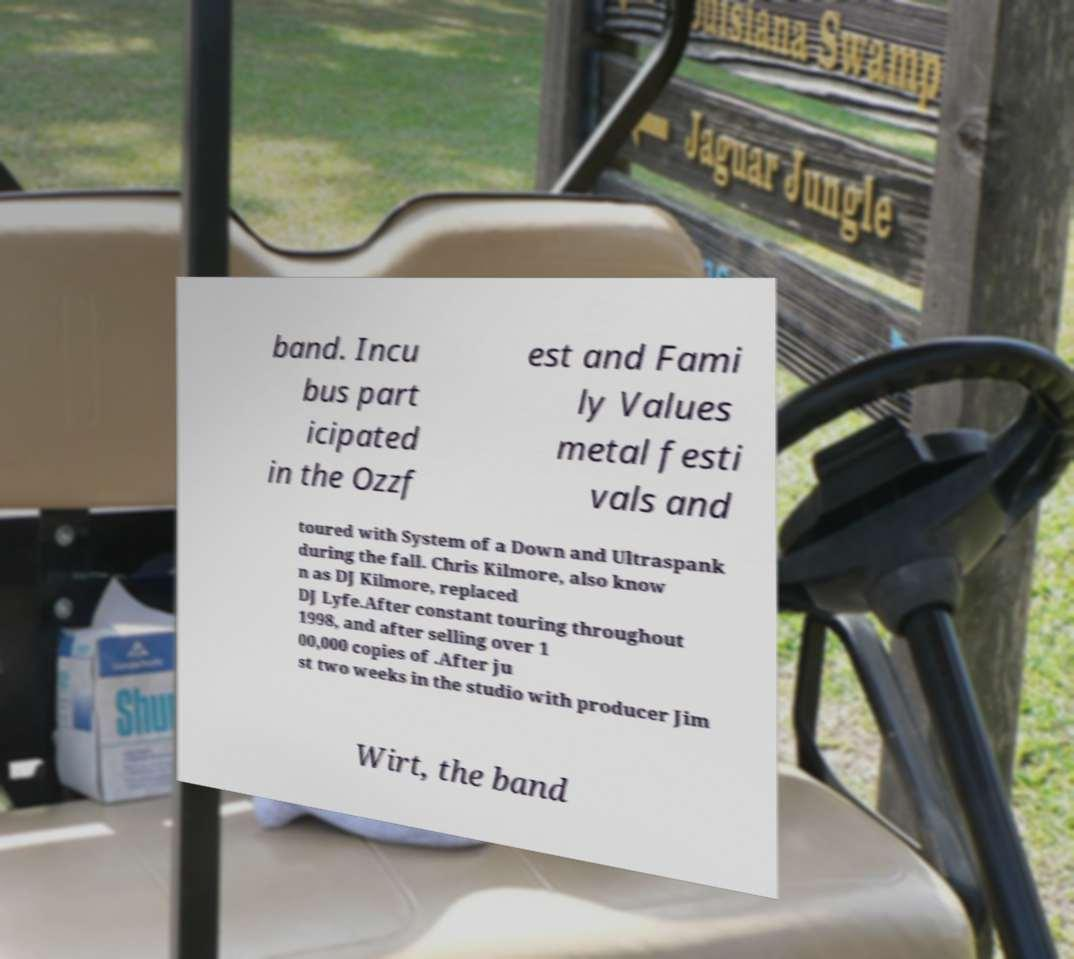Can you read and provide the text displayed in the image?This photo seems to have some interesting text. Can you extract and type it out for me? band. Incu bus part icipated in the Ozzf est and Fami ly Values metal festi vals and toured with System of a Down and Ultraspank during the fall. Chris Kilmore, also know n as DJ Kilmore, replaced DJ Lyfe.After constant touring throughout 1998, and after selling over 1 00,000 copies of .After ju st two weeks in the studio with producer Jim Wirt, the band 